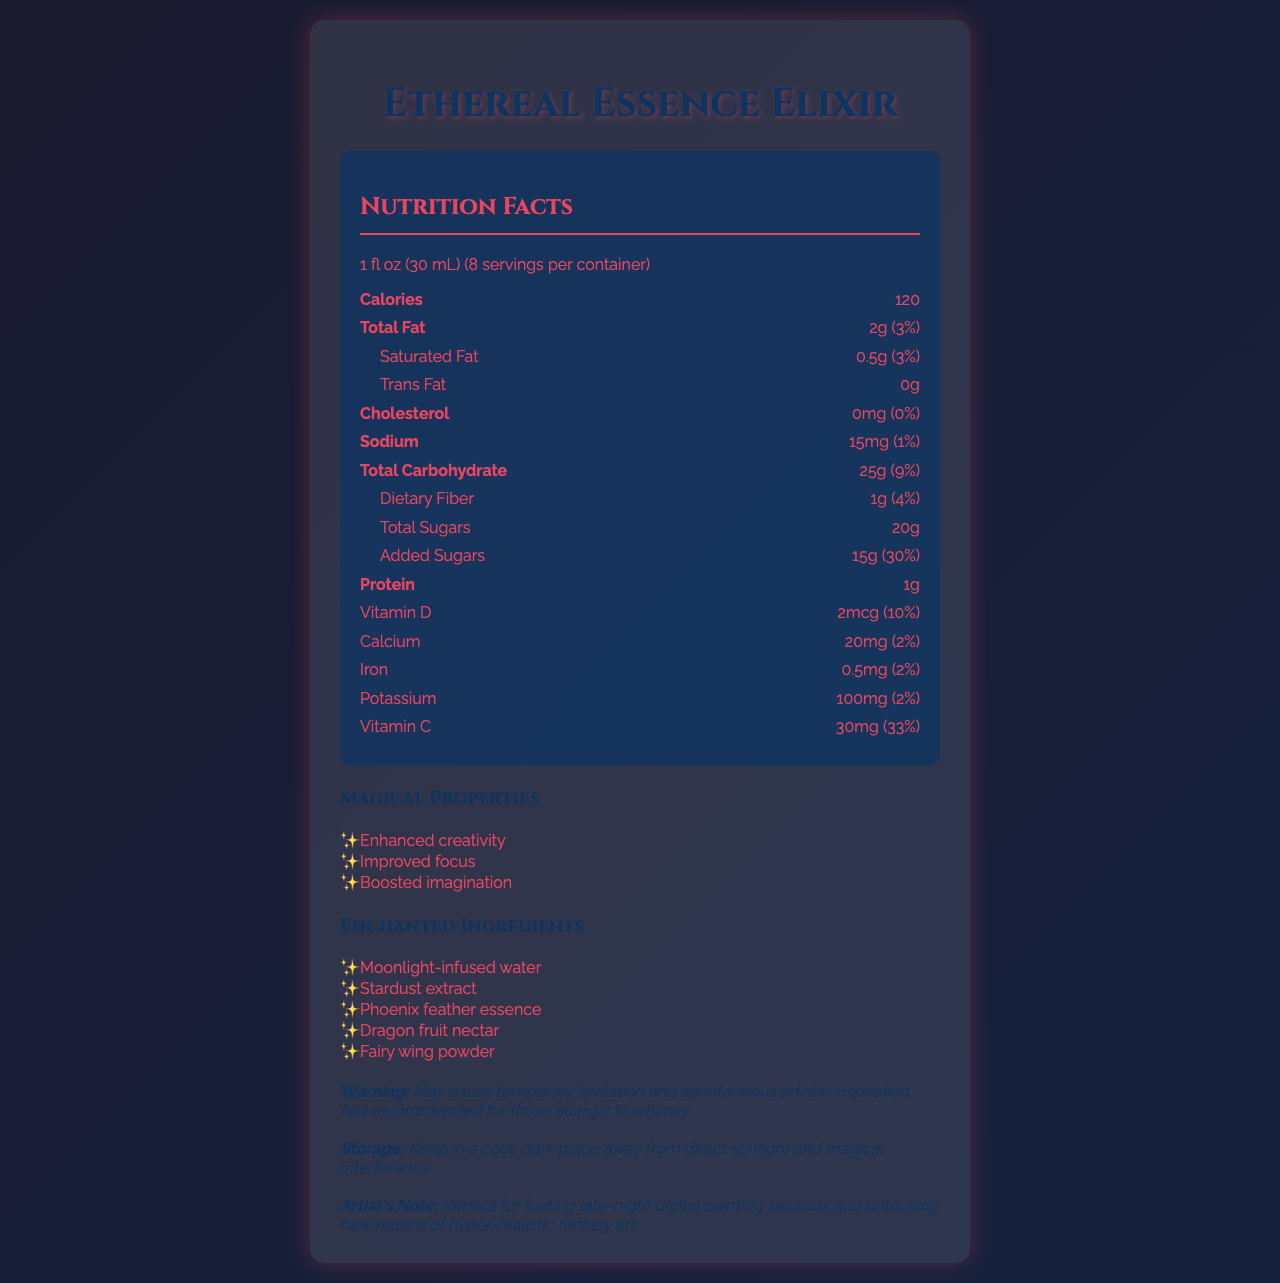what is the serving size? The serving size is explicitly mentioned in the document as "1 fl oz (30 mL)".
Answer: 1 fl oz (30 mL) how many servings are there per container? The document specifies that there are 8 servings per container.
Answer: 8 what is the total number of calories per serving? The document states that each serving contains 120 calories.
Answer: 120 which nutrient has the highest daily value percentage? Among the listed nutrients, Vitamin C has the highest daily value percentage at 33%.
Answer: Vitamin C with 33% name one of the enchanted ingredients in the Ethereal Essence Elixir. Stardust extract is listed as one of the enchanted ingredients.
Answer: Stardust extract how much added sugars are in one serving? The document lists 15g of added sugars per serving.
Answer: 15g how should the Ethereal Essence Elixir be stored? The storage instructions are to keep it in a cool, dark place away from direct sunlight and magical interference.
Answer: Keep in a cool, dark place away from direct sunlight and magical interference. which nutrient contains 0mg per serving? The document shows that cholesterol has 0mg per serving.
Answer: Cholesterol which of the following is not a magical property of the elixir? A. Enhanced creativity B. Improved memory C. Boosted imagination Improved memory is not listed as one of the magical properties; the correct magical properties are Enhanced creativity, Improved focus, and Boosted imagination.
Answer: B how many grams of dietary fiber are in one serving? A. 0g B. 1g C. 2g D. 5g The document indicates that one serving contains 1g of dietary fiber.
Answer: B does the elixir contain any trans fat? The document states that the elixir contains 0g of trans fat.
Answer: No is this product recommended for those allergic to whimsy? The warning clearly mentions that the product is not recommended for those allergic to whimsy.
Answer: No summarize the main idea of the document. The document is a detailed overview of the nutritional content, magical properties, and essential information regarding the Ethereal Essence Elixir.
Answer: This document provides the nutrition information of the Ethereal Essence Elixir, including its serving size, calorie content, and nutrient values per serving. It also lists magical properties and enchanted ingredients and provides warnings and storage instructions. can you prepare this elixir at home? The document does not provide any information on how the elixir is prepared or if it can be made at home.
Answer: Cannot be determined 